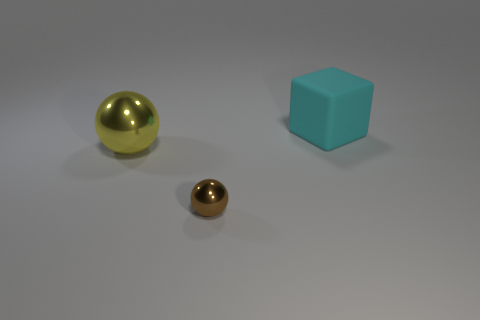Add 1 cyan matte things. How many objects exist? 4 Subtract all balls. How many objects are left? 1 Add 3 shiny spheres. How many shiny spheres are left? 5 Add 3 brown balls. How many brown balls exist? 4 Subtract 0 purple cylinders. How many objects are left? 3 Subtract all balls. Subtract all big red spheres. How many objects are left? 1 